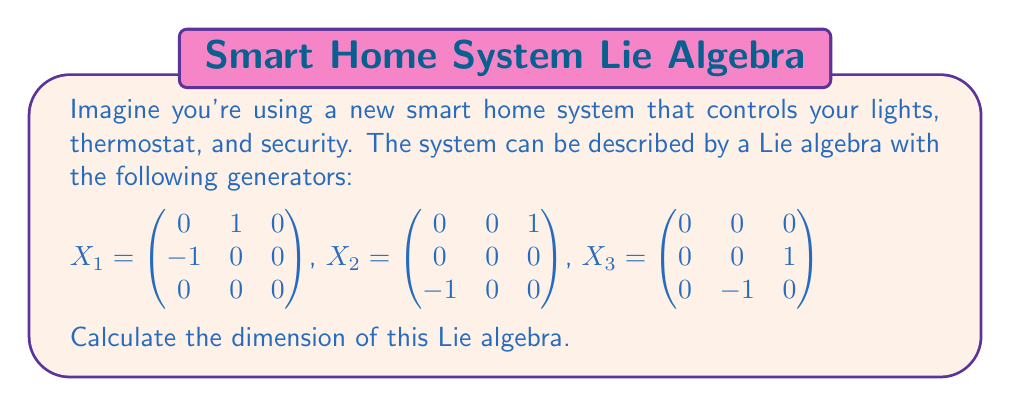Give your solution to this math problem. To find the dimension of a Lie algebra given its generators, we need to determine the number of linearly independent elements in the algebra. This involves the following steps:

1) First, we start with the given generators $X_1$, $X_2$, and $X_3$.

2) We then compute all possible Lie brackets between these generators. The Lie bracket of two matrices $A$ and $B$ is defined as $[A,B] = AB - BA$.

3) Let's calculate these brackets:

   $[X_1, X_2] = X_1X_2 - X_2X_1 = \begin{pmatrix} 0 & 0 & 0 \\ 0 & 0 & -1 \\ 1 & 0 & 0 \end{pmatrix} = X_3$

   $[X_1, X_3] = X_1X_3 - X_3X_1 = \begin{pmatrix} 0 & 0 & -1 \\ 0 & 0 & 0 \\ 0 & 1 & 0 \end{pmatrix} = -X_2$

   $[X_2, X_3] = X_2X_3 - X_3X_2 = \begin{pmatrix} 1 & 0 & 0 \\ 0 & 0 & 0 \\ 0 & 0 & -1 \end{pmatrix} = X_1$

4) We see that all Lie brackets result in generators we already have. This means that the Lie algebra is closed under the Lie bracket operation with just these three generators.

5) Now, we need to check if these generators are linearly independent. We can see that they are, as each generator has a non-zero entry in a position where the others have zero entries.

6) Since we have three linearly independent generators, and all Lie brackets result in linear combinations of these generators, we can conclude that the dimension of the Lie algebra is 3.

This Lie algebra is actually isomorphic to $so(3)$, the special orthogonal Lie algebra in three dimensions, which represents rotations in 3D space. In the context of the smart home system, this could represent the ability to adjust settings (like temperature or light intensity) in three independent directions.
Answer: The dimension of the Lie algebra is 3. 